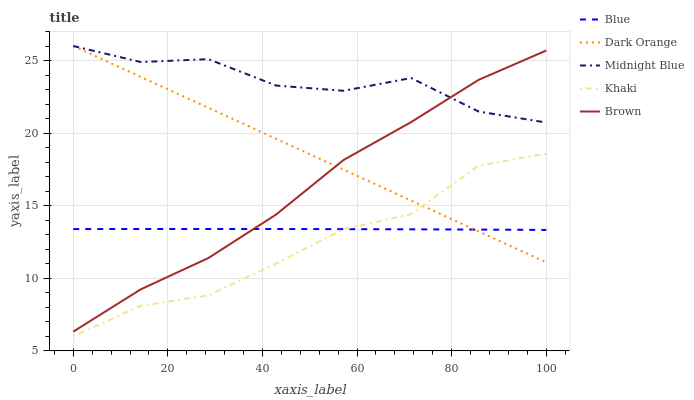Does Khaki have the minimum area under the curve?
Answer yes or no. Yes. Does Midnight Blue have the maximum area under the curve?
Answer yes or no. Yes. Does Dark Orange have the minimum area under the curve?
Answer yes or no. No. Does Dark Orange have the maximum area under the curve?
Answer yes or no. No. Is Dark Orange the smoothest?
Answer yes or no. Yes. Is Midnight Blue the roughest?
Answer yes or no. Yes. Is Khaki the smoothest?
Answer yes or no. No. Is Khaki the roughest?
Answer yes or no. No. Does Dark Orange have the lowest value?
Answer yes or no. No. Does Khaki have the highest value?
Answer yes or no. No. Is Khaki less than Brown?
Answer yes or no. Yes. Is Brown greater than Khaki?
Answer yes or no. Yes. Does Khaki intersect Brown?
Answer yes or no. No. 